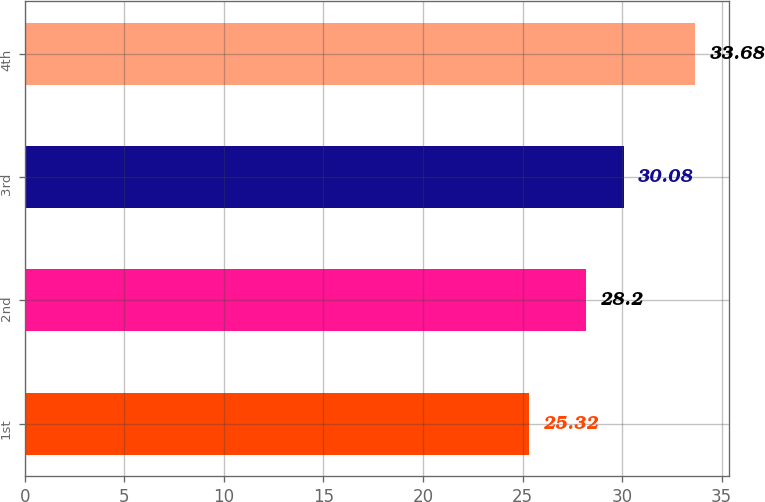Convert chart to OTSL. <chart><loc_0><loc_0><loc_500><loc_500><bar_chart><fcel>1st<fcel>2nd<fcel>3rd<fcel>4th<nl><fcel>25.32<fcel>28.2<fcel>30.08<fcel>33.68<nl></chart> 